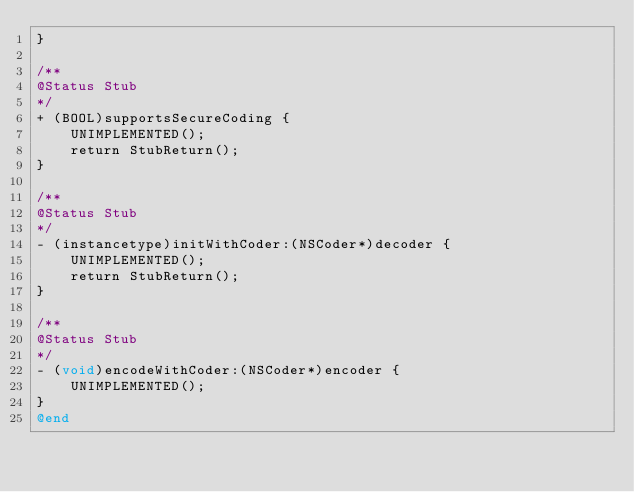<code> <loc_0><loc_0><loc_500><loc_500><_ObjectiveC_>}

/**
@Status Stub
*/
+ (BOOL)supportsSecureCoding {
    UNIMPLEMENTED();
    return StubReturn();
}

/**
@Status Stub
*/
- (instancetype)initWithCoder:(NSCoder*)decoder {
    UNIMPLEMENTED();
    return StubReturn();
}

/**
@Status Stub
*/
- (void)encodeWithCoder:(NSCoder*)encoder {
    UNIMPLEMENTED();
}
@end
</code> 